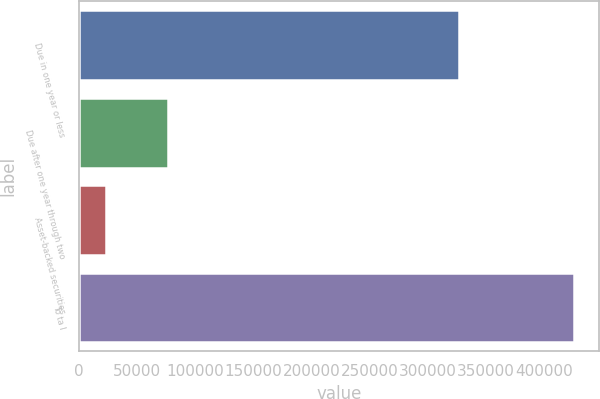Convert chart to OTSL. <chart><loc_0><loc_0><loc_500><loc_500><bar_chart><fcel>Due in one year or less<fcel>Due after one year through two<fcel>Asset-backed securities<fcel>To ta l<nl><fcel>326694<fcel>76325<fcel>23113<fcel>426132<nl></chart> 